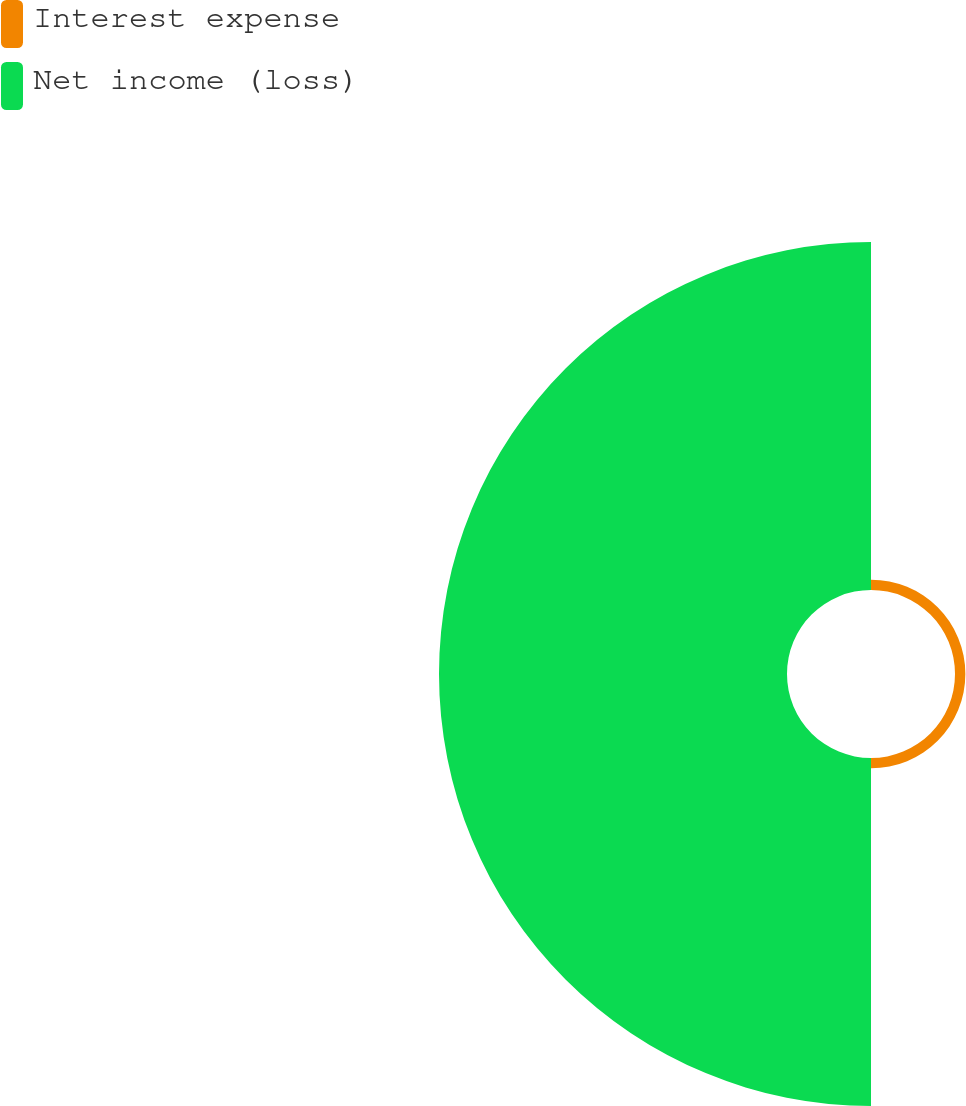Convert chart to OTSL. <chart><loc_0><loc_0><loc_500><loc_500><pie_chart><fcel>Interest expense<fcel>Net income (loss)<nl><fcel>2.89%<fcel>97.11%<nl></chart> 